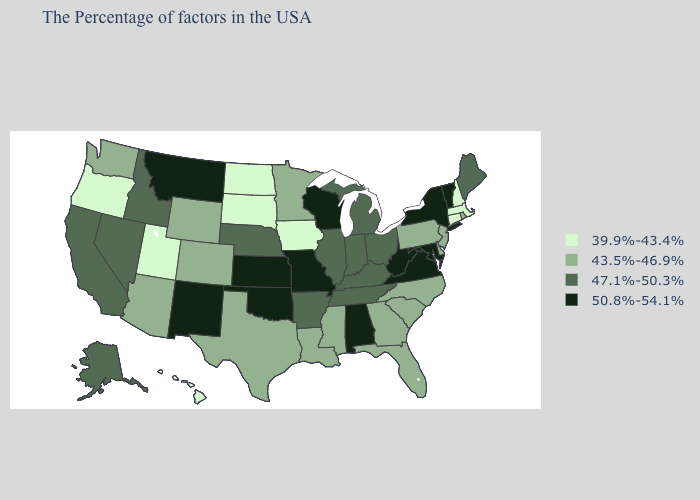Among the states that border Indiana , which have the lowest value?
Give a very brief answer. Ohio, Michigan, Kentucky, Illinois. What is the lowest value in the West?
Concise answer only. 39.9%-43.4%. Which states have the lowest value in the South?
Write a very short answer. Delaware, North Carolina, South Carolina, Florida, Georgia, Mississippi, Louisiana, Texas. What is the lowest value in the West?
Give a very brief answer. 39.9%-43.4%. Does the map have missing data?
Short answer required. No. Which states have the highest value in the USA?
Be succinct. Vermont, New York, Maryland, Virginia, West Virginia, Alabama, Wisconsin, Missouri, Kansas, Oklahoma, New Mexico, Montana. What is the value of Arkansas?
Short answer required. 47.1%-50.3%. What is the value of Kansas?
Be succinct. 50.8%-54.1%. What is the highest value in the MidWest ?
Answer briefly. 50.8%-54.1%. Which states have the lowest value in the USA?
Concise answer only. Massachusetts, New Hampshire, Connecticut, Iowa, South Dakota, North Dakota, Utah, Oregon, Hawaii. Does Texas have the lowest value in the South?
Give a very brief answer. Yes. Name the states that have a value in the range 50.8%-54.1%?
Give a very brief answer. Vermont, New York, Maryland, Virginia, West Virginia, Alabama, Wisconsin, Missouri, Kansas, Oklahoma, New Mexico, Montana. What is the value of Arkansas?
Keep it brief. 47.1%-50.3%. Name the states that have a value in the range 43.5%-46.9%?
Short answer required. Rhode Island, New Jersey, Delaware, Pennsylvania, North Carolina, South Carolina, Florida, Georgia, Mississippi, Louisiana, Minnesota, Texas, Wyoming, Colorado, Arizona, Washington. Among the states that border Michigan , does Wisconsin have the lowest value?
Give a very brief answer. No. 